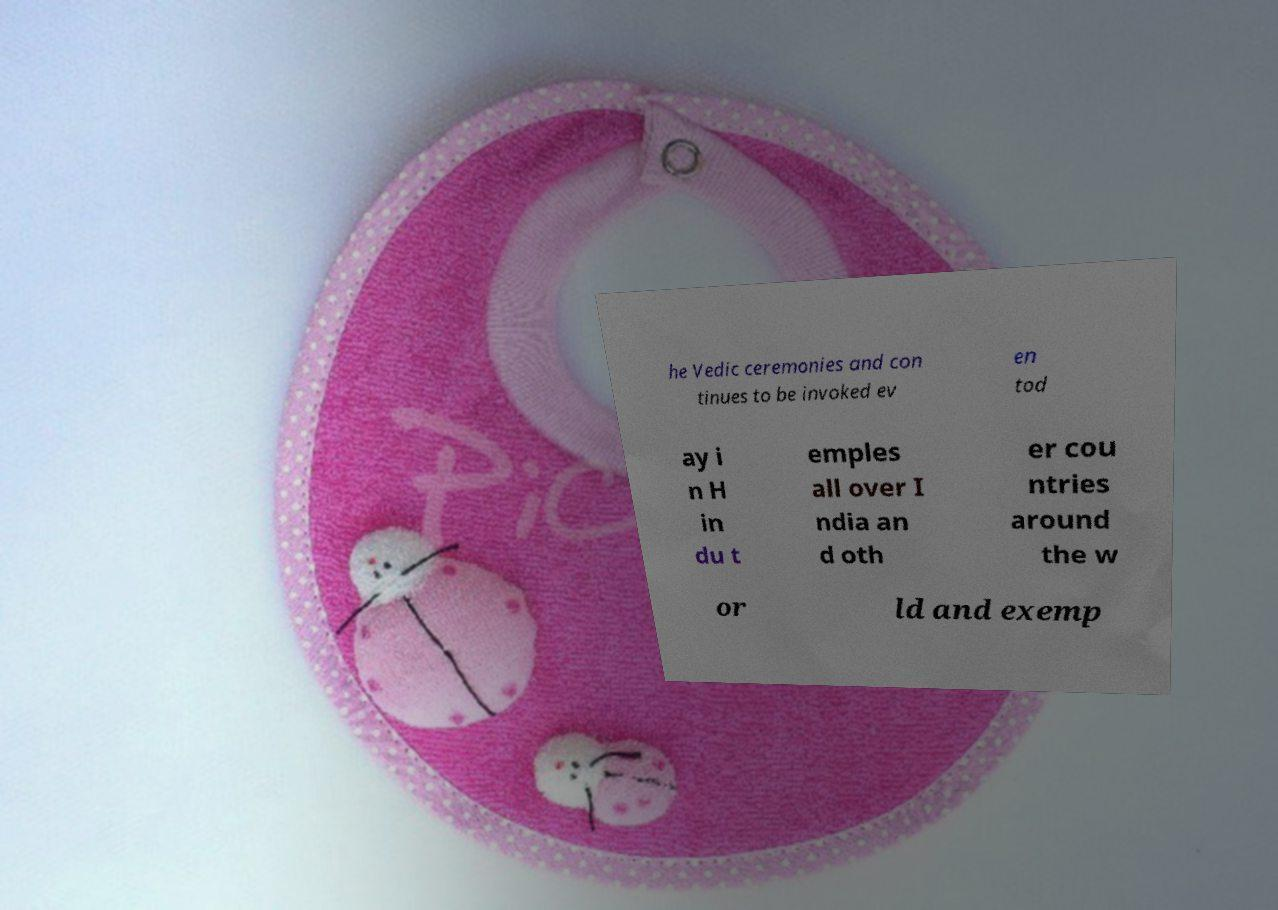Can you accurately transcribe the text from the provided image for me? he Vedic ceremonies and con tinues to be invoked ev en tod ay i n H in du t emples all over I ndia an d oth er cou ntries around the w or ld and exemp 